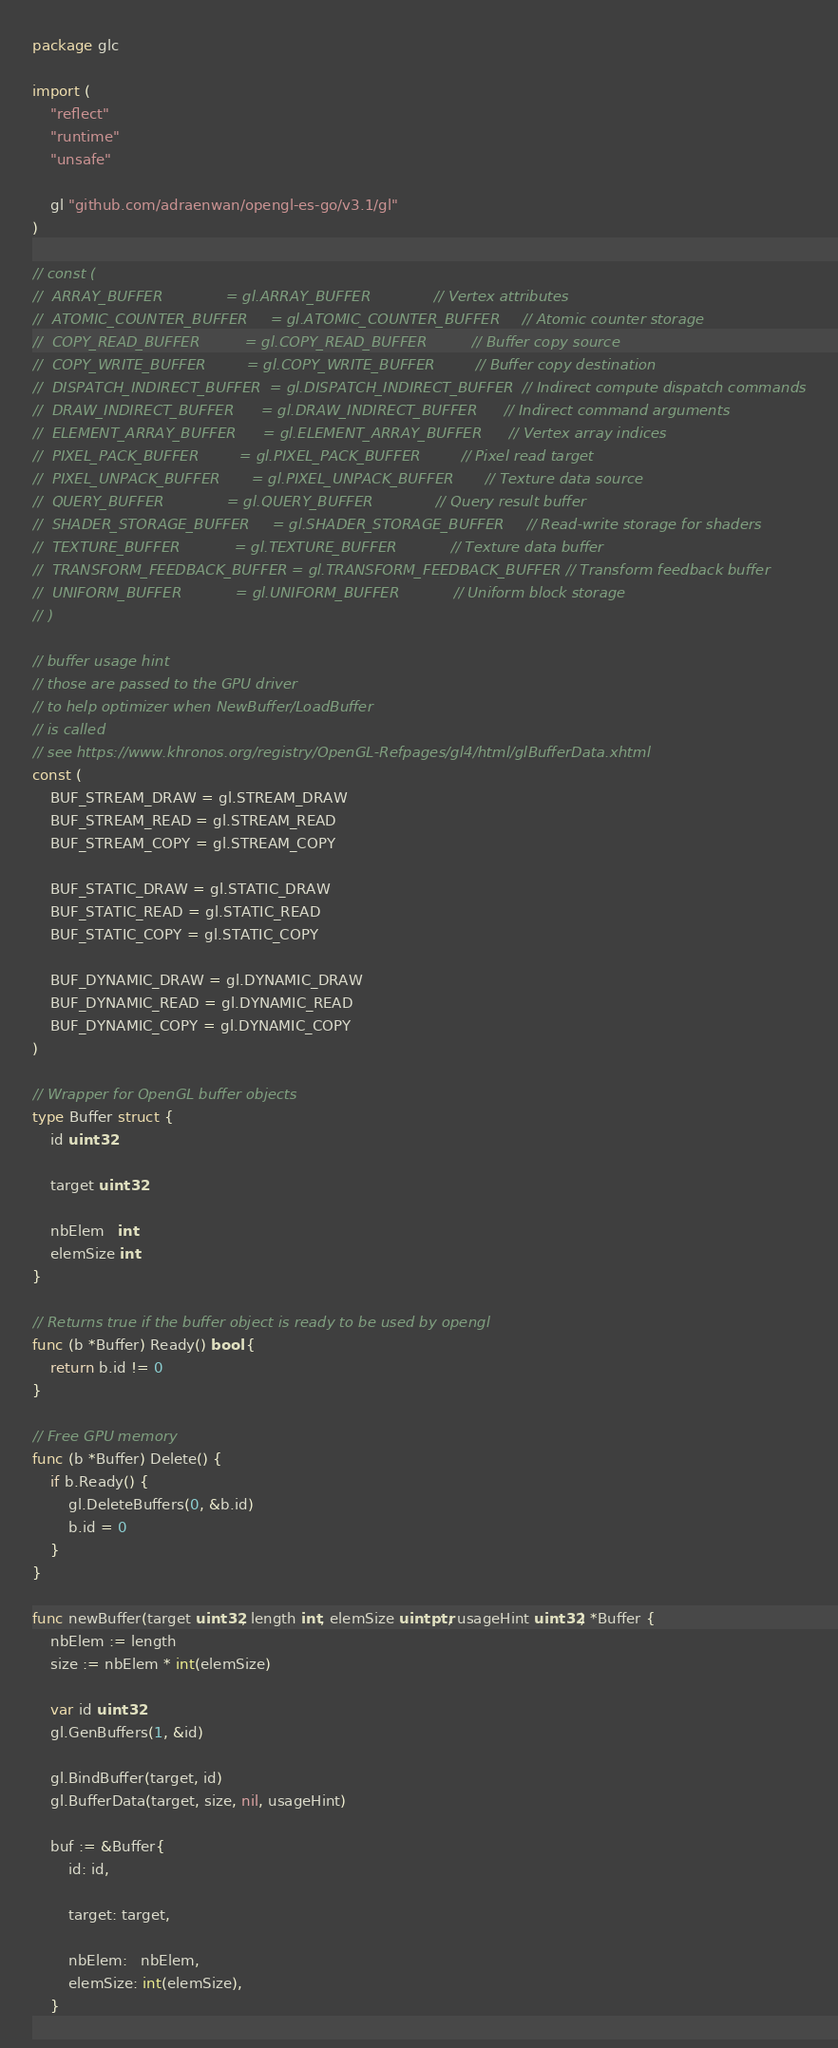<code> <loc_0><loc_0><loc_500><loc_500><_Go_>package glc

import (
	"reflect"
	"runtime"
	"unsafe"

	gl "github.com/adraenwan/opengl-es-go/v3.1/gl"
)

// const (
// 	ARRAY_BUFFER              = gl.ARRAY_BUFFER              // Vertex attributes
// 	ATOMIC_COUNTER_BUFFER     = gl.ATOMIC_COUNTER_BUFFER     // Atomic counter storage
// 	COPY_READ_BUFFER          = gl.COPY_READ_BUFFER          // Buffer copy source
// 	COPY_WRITE_BUFFER         = gl.COPY_WRITE_BUFFER         // Buffer copy destination
// 	DISPATCH_INDIRECT_BUFFER  = gl.DISPATCH_INDIRECT_BUFFER  // Indirect compute dispatch commands
// 	DRAW_INDIRECT_BUFFER      = gl.DRAW_INDIRECT_BUFFER      // Indirect command arguments
// 	ELEMENT_ARRAY_BUFFER      = gl.ELEMENT_ARRAY_BUFFER      // Vertex array indices
// 	PIXEL_PACK_BUFFER         = gl.PIXEL_PACK_BUFFER         // Pixel read target
// 	PIXEL_UNPACK_BUFFER       = gl.PIXEL_UNPACK_BUFFER       // Texture data source
// 	QUERY_BUFFER              = gl.QUERY_BUFFER              // Query result buffer
// 	SHADER_STORAGE_BUFFER     = gl.SHADER_STORAGE_BUFFER     // Read-write storage for shaders
// 	TEXTURE_BUFFER            = gl.TEXTURE_BUFFER            // Texture data buffer
// 	TRANSFORM_FEEDBACK_BUFFER = gl.TRANSFORM_FEEDBACK_BUFFER // Transform feedback buffer
// 	UNIFORM_BUFFER            = gl.UNIFORM_BUFFER            // Uniform block storage
// )

// buffer usage hint
// those are passed to the GPU driver
// to help optimizer when NewBuffer/LoadBuffer
// is called
// see https://www.khronos.org/registry/OpenGL-Refpages/gl4/html/glBufferData.xhtml
const (
	BUF_STREAM_DRAW = gl.STREAM_DRAW
	BUF_STREAM_READ = gl.STREAM_READ
	BUF_STREAM_COPY = gl.STREAM_COPY

	BUF_STATIC_DRAW = gl.STATIC_DRAW
	BUF_STATIC_READ = gl.STATIC_READ
	BUF_STATIC_COPY = gl.STATIC_COPY

	BUF_DYNAMIC_DRAW = gl.DYNAMIC_DRAW
	BUF_DYNAMIC_READ = gl.DYNAMIC_READ
	BUF_DYNAMIC_COPY = gl.DYNAMIC_COPY
)

// Wrapper for OpenGL buffer objects
type Buffer struct {
	id uint32

	target uint32

	nbElem   int
	elemSize int
}

// Returns true if the buffer object is ready to be used by opengl
func (b *Buffer) Ready() bool {
	return b.id != 0
}

// Free GPU memory
func (b *Buffer) Delete() {
	if b.Ready() {
		gl.DeleteBuffers(0, &b.id)
		b.id = 0
	}
}

func newBuffer(target uint32, length int, elemSize uintptr, usageHint uint32) *Buffer {
	nbElem := length
	size := nbElem * int(elemSize)

	var id uint32
	gl.GenBuffers(1, &id)

	gl.BindBuffer(target, id)
	gl.BufferData(target, size, nil, usageHint)

	buf := &Buffer{
		id: id,

		target: target,

		nbElem:   nbElem,
		elemSize: int(elemSize),
	}
</code> 